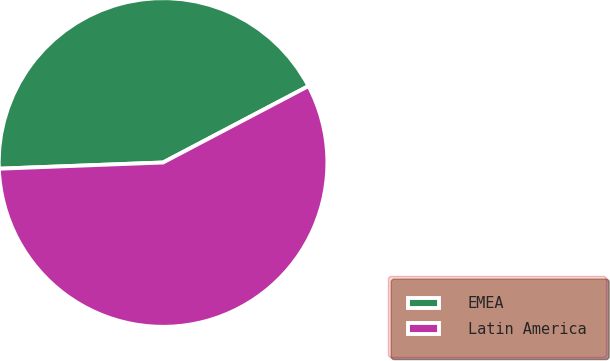<chart> <loc_0><loc_0><loc_500><loc_500><pie_chart><fcel>EMEA<fcel>Latin America<nl><fcel>42.9%<fcel>57.1%<nl></chart> 